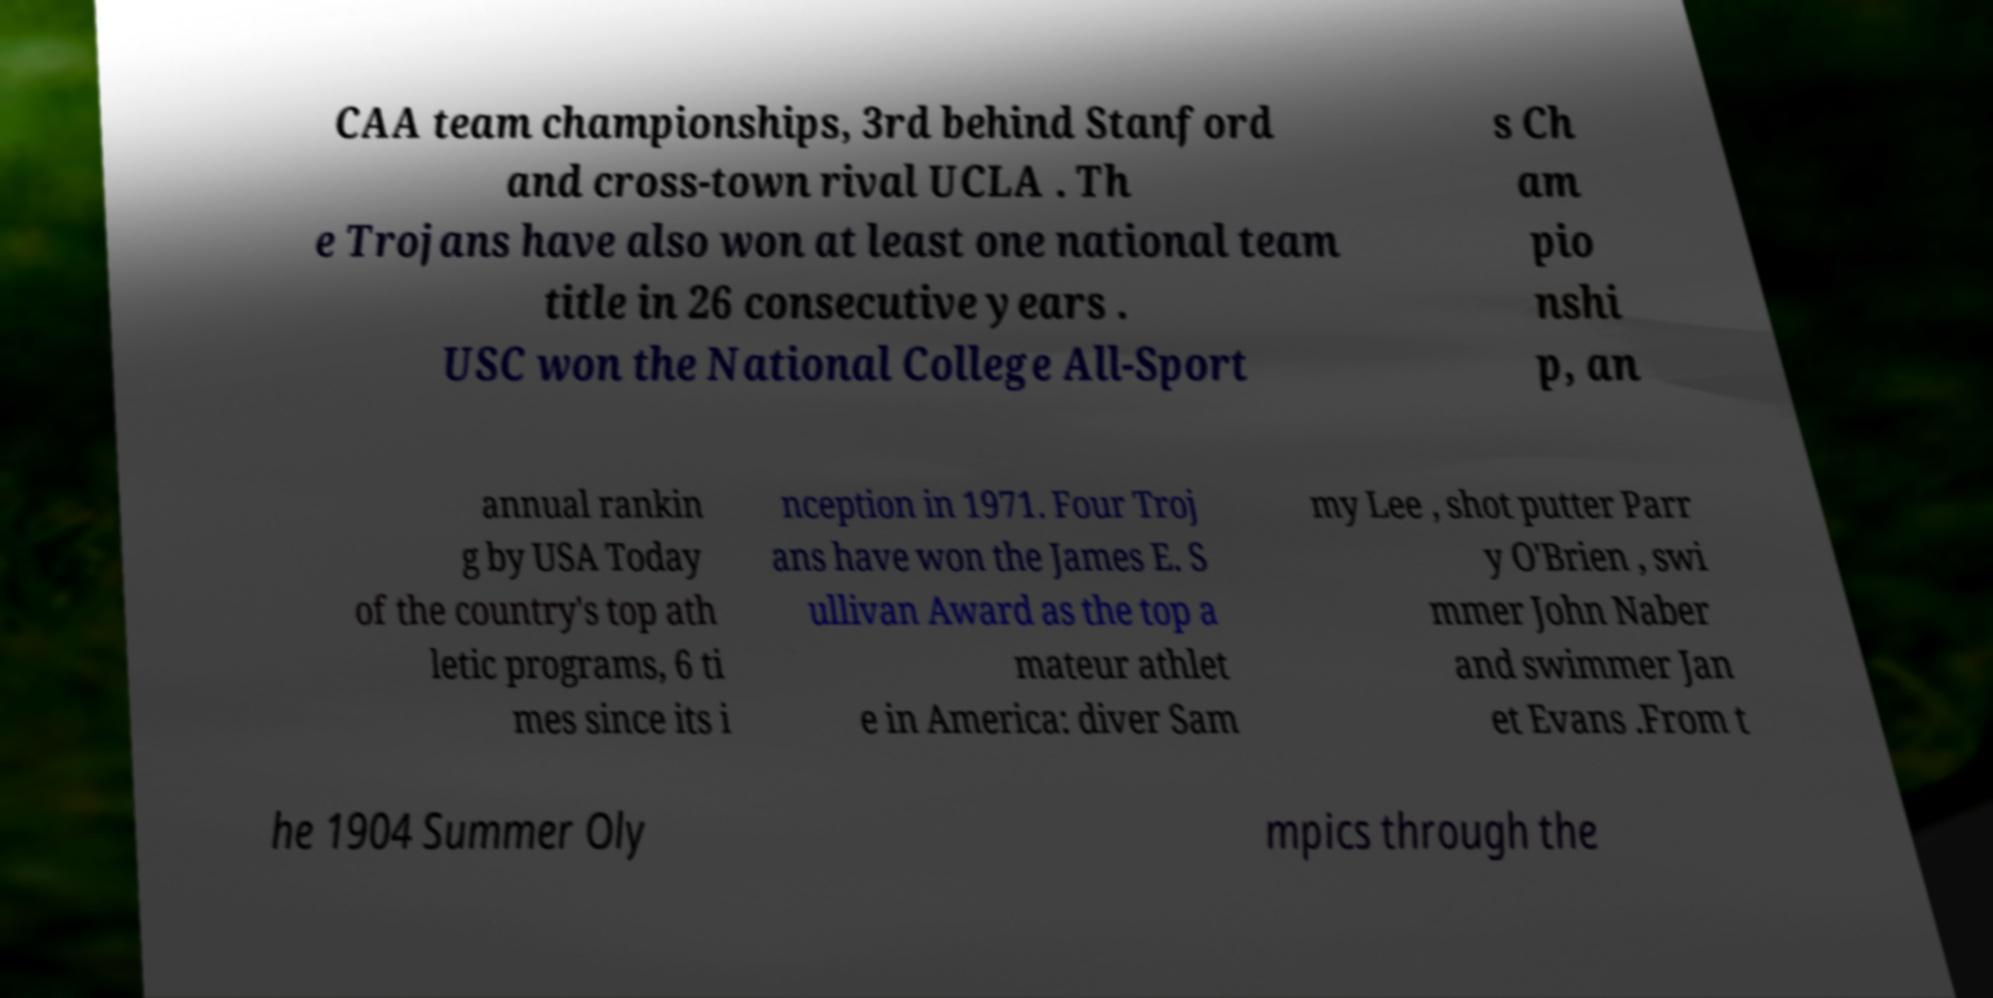What messages or text are displayed in this image? I need them in a readable, typed format. CAA team championships, 3rd behind Stanford and cross-town rival UCLA . Th e Trojans have also won at least one national team title in 26 consecutive years . USC won the National College All-Sport s Ch am pio nshi p, an annual rankin g by USA Today of the country's top ath letic programs, 6 ti mes since its i nception in 1971. Four Troj ans have won the James E. S ullivan Award as the top a mateur athlet e in America: diver Sam my Lee , shot putter Parr y O'Brien , swi mmer John Naber and swimmer Jan et Evans .From t he 1904 Summer Oly mpics through the 